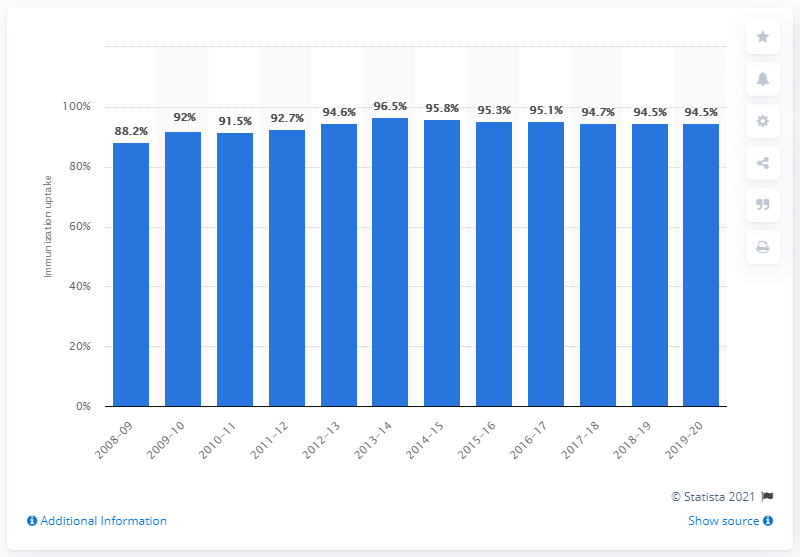Give some essential details in this illustration. The immunization rate of the MMR vaccine in the years 2018/19 and 2019/20 was 94.5%. 